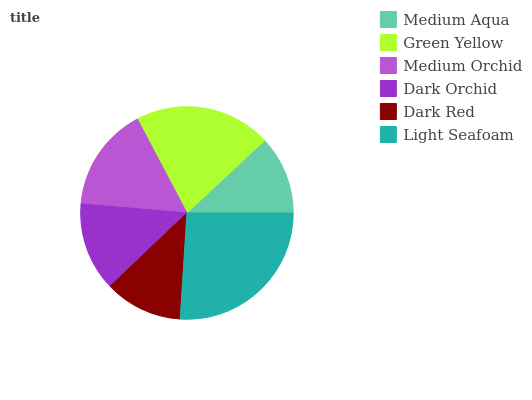Is Dark Red the minimum?
Answer yes or no. Yes. Is Light Seafoam the maximum?
Answer yes or no. Yes. Is Green Yellow the minimum?
Answer yes or no. No. Is Green Yellow the maximum?
Answer yes or no. No. Is Green Yellow greater than Medium Aqua?
Answer yes or no. Yes. Is Medium Aqua less than Green Yellow?
Answer yes or no. Yes. Is Medium Aqua greater than Green Yellow?
Answer yes or no. No. Is Green Yellow less than Medium Aqua?
Answer yes or no. No. Is Medium Orchid the high median?
Answer yes or no. Yes. Is Dark Orchid the low median?
Answer yes or no. Yes. Is Dark Orchid the high median?
Answer yes or no. No. Is Green Yellow the low median?
Answer yes or no. No. 